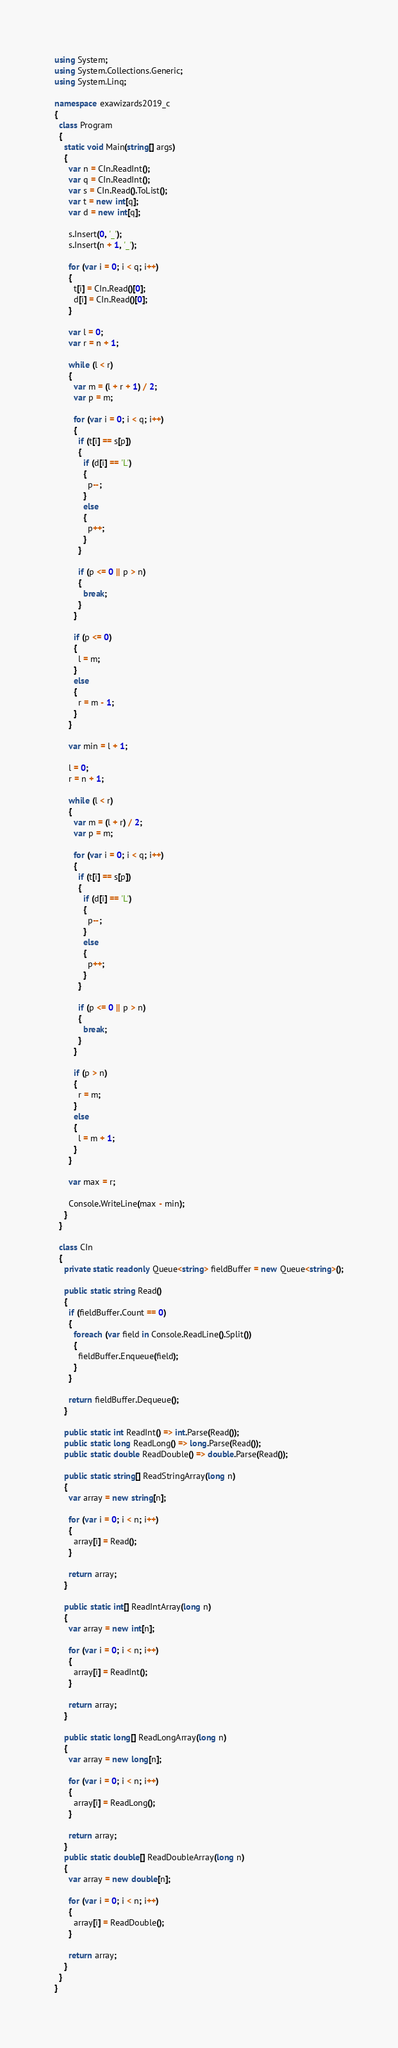Convert code to text. <code><loc_0><loc_0><loc_500><loc_500><_C#_>using System;
using System.Collections.Generic;
using System.Linq;

namespace exawizards2019_c
{
  class Program
  {
    static void Main(string[] args)
    {
      var n = CIn.ReadInt();
      var q = CIn.ReadInt();
      var s = CIn.Read().ToList();
      var t = new int[q];
      var d = new int[q];

      s.Insert(0, '_');
      s.Insert(n + 1, '_');

      for (var i = 0; i < q; i++)
      {
        t[i] = CIn.Read()[0];
        d[i] = CIn.Read()[0];
      }

      var l = 0;
      var r = n + 1;

      while (l < r)
      {
        var m = (l + r + 1) / 2;
        var p = m;

        for (var i = 0; i < q; i++)
        {
          if (t[i] == s[p])
          {
            if (d[i] == 'L')
            {
              p--;
            }
            else
            {
              p++;
            }
          }

          if (p <= 0 || p > n)
          {
            break;
          }
        }

        if (p <= 0)
        {
          l = m;
        }
        else
        {
          r = m - 1;
        }
      }

      var min = l + 1;

      l = 0;
      r = n + 1;

      while (l < r)
      {
        var m = (l + r) / 2;
        var p = m;

        for (var i = 0; i < q; i++)
        {
          if (t[i] == s[p])
          {
            if (d[i] == 'L')
            {
              p--;
            }
            else
            {
              p++;
            }
          }

          if (p <= 0 || p > n)
          {
            break;
          }
        }

        if (p > n)
        {
          r = m;
        }
        else
        {
          l = m + 1;
        }
      }

      var max = r;

      Console.WriteLine(max - min);
    }
  }

  class CIn
  {
    private static readonly Queue<string> fieldBuffer = new Queue<string>();

    public static string Read()
    {
      if (fieldBuffer.Count == 0)
      {
        foreach (var field in Console.ReadLine().Split())
        {
          fieldBuffer.Enqueue(field);
        }
      }

      return fieldBuffer.Dequeue();
    }

    public static int ReadInt() => int.Parse(Read());
    public static long ReadLong() => long.Parse(Read());
    public static double ReadDouble() => double.Parse(Read());

    public static string[] ReadStringArray(long n)
    {
      var array = new string[n];

      for (var i = 0; i < n; i++)
      {
        array[i] = Read();
      }

      return array;
    }

    public static int[] ReadIntArray(long n)
    {
      var array = new int[n];

      for (var i = 0; i < n; i++)
      {
        array[i] = ReadInt();
      }

      return array;
    }

    public static long[] ReadLongArray(long n)
    {
      var array = new long[n];

      for (var i = 0; i < n; i++)
      {
        array[i] = ReadLong();
      }

      return array;
    }
    public static double[] ReadDoubleArray(long n)
    {
      var array = new double[n];

      for (var i = 0; i < n; i++)
      {
        array[i] = ReadDouble();
      }

      return array;
    }
  }
}</code> 